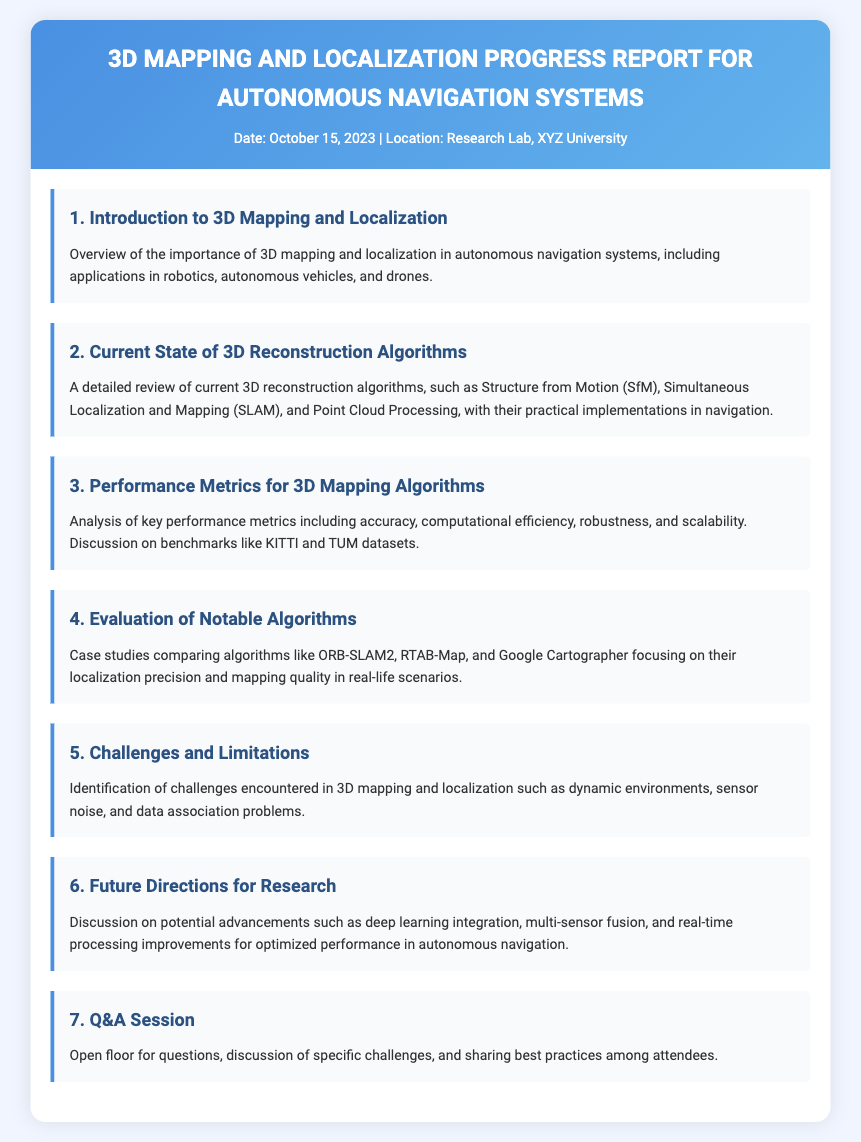What is the date of the report? The date of the report is explicitly stated in the document header.
Answer: October 15, 2023 Where is the report being presented? The location of the report presentation is mentioned in the header of the document.
Answer: Research Lab, XYZ University What is the title of the second agenda item? The title of the second agenda item is found in the list of agenda items.
Answer: Current State of 3D Reconstruction Algorithms What performance metrics are discussed in the third agenda item? The third agenda item specifically mentions key performance metrics related to 3D mapping algorithms.
Answer: Accuracy, computational efficiency, robustness, and scalability Which algorithms are evaluated in the fourth agenda item? The fourth agenda item lists the algorithms that are being evaluated in case studies.
Answer: ORB-SLAM2, RTAB-Map, Google Cartographer What is one major challenge mentioned in the fifth agenda item? The fifth agenda item identifies a challenge encountered in 3D mapping and localization.
Answer: Dynamic environments What future advancement is discussed in the sixth agenda item? The sixth agenda item covers potential advancements in research for 3D mapping and localization.
Answer: Deep learning integration What type of session is mentioned in the seventh agenda item? The seventh agenda item describes the type of session that will take place at the end of the report.
Answer: Q&A Session 